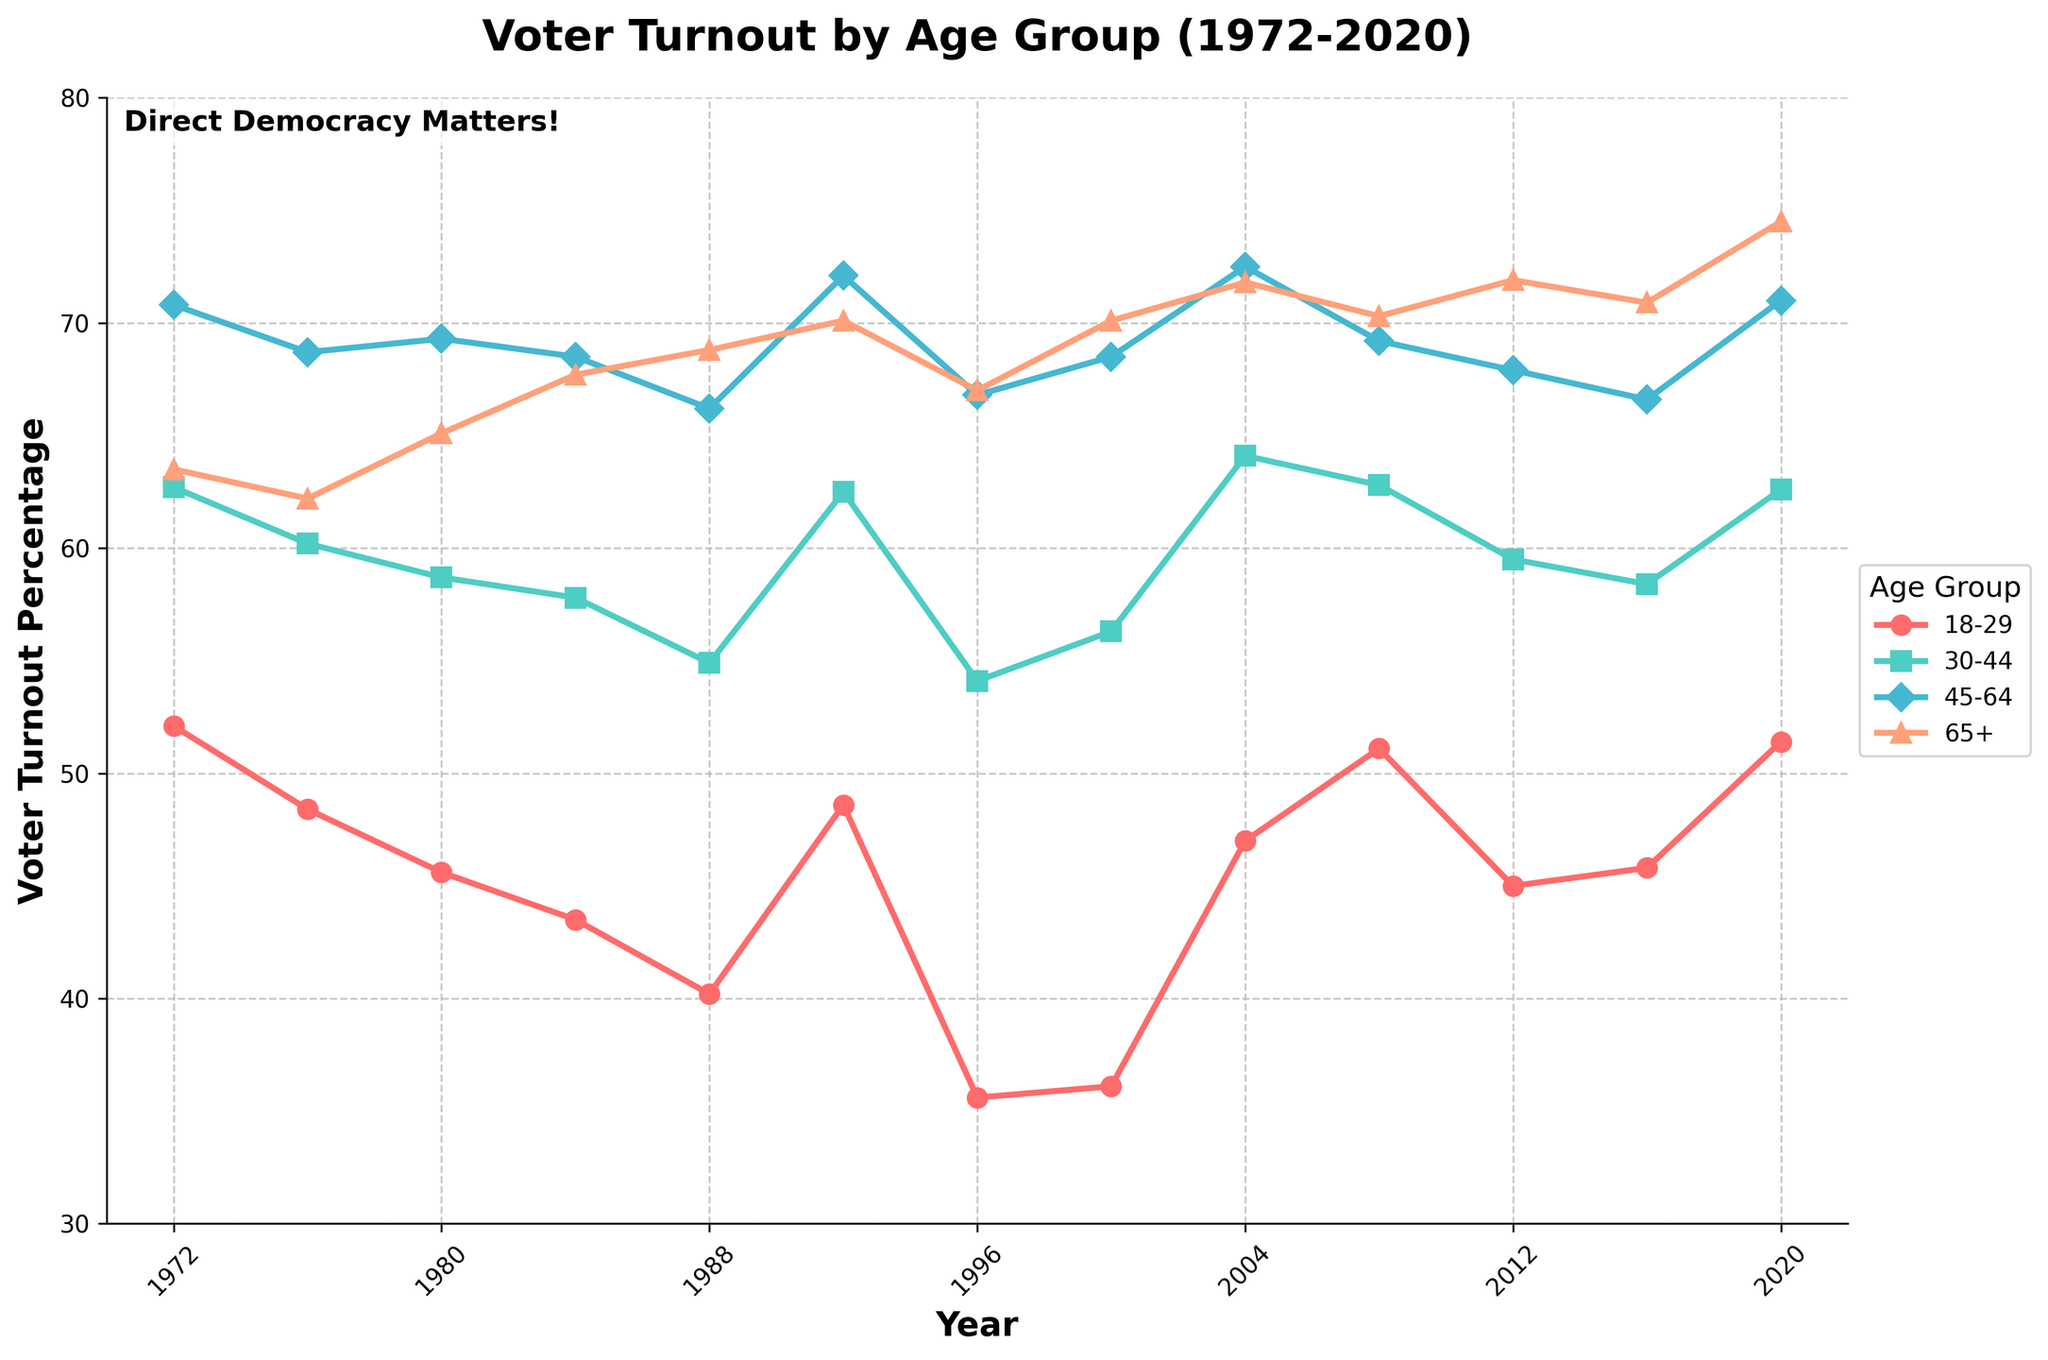What is the overall trend for voter turnout in the 18-29 age group from 1972 to 2020? Over the years, we can observe the plotted line for the 18-29 age group. The line shows fluctuations but has a decreasing trend initially, hitting around 35.6% in 1996, followed by an increase to 51.4% in 2020.
Answer: Decreasing initially, then increasing Which age group has consistently had the highest voter turnout over the past 50 years? By examining the lines on the graph, it is clear that the 65+ age group consistently has the highest voter turnout percentage throughout the years.
Answer: 65+ During which national election year did the age group 30-44 experience the highest voter turnout? From the plot, we observe the peak points for the line corresponding to the 30-44 age group. The highest point appears around the year 2004 with a turnout of 64.1%.
Answer: 2004 How does the voter turnout in 2016 compare between the 18-29 and 65+ age groups? We compare the points for the year 2016 on the graph. For the 18-29 age group, turnout is 45.8%, and for the 65+ group, it is 70.9%.
Answer: 65+ group had higher turnout What is the difference in voter turnout percentage for the 45-64 age group between 1972 and 1996? Looking at the line for the 45-64 age group, the turnout in 1972 is 70.8% and in 1996 is 66.8%. The difference is calculated as 70.8% - 66.8% = 4%.
Answer: 4% Which election year shows the smallest gap in voter turnout between the 18-29 and 65+ age groups? Comparing the gaps for different years, the smallest gap is in the year 2008, with 51.1% for 18-29 and 70.3% for 65+. The gap is 70.3% - 51.1% = 19.2%.
Answer: 2008 How did the voter turnout trend change for the 45-64 age group from 1976 to 1988? Observing the line for the 45-64 age group from 1976 (68.7%) to 1988 (66.2%), we see a decrease in voter turnout. The trend goes downward.
Answer: Decreased What is the average voter turnout for the 65+ age group between 2000 and 2020? The values for 2000, 2004, 2008, 2012, 2016, and 2020 are added and then divided by the number of years: (70.1+71.8+70.3+71.9+70.9+74.5)/6 = 71.58%.
Answer: 71.58% Which age group showed the most variability in voter turnout percentages from 1972 to 2020? By visually comparing the amplitude of the fluctuations of each line, it is clear that the 18-29 age group has the most variability, as the changes in turnout are more drastic.
Answer: 18-29 How does the overall voter turnout pattern differ between the 18-29 and 45-64 age groups over the past 50 years? The 18-29 age group has a more variable pattern with significant drops and rises, while the 45-64 age group shows a relatively stable pattern with gradual decreases and increases.
Answer: 18-29: More variable, 45-64: More stable 